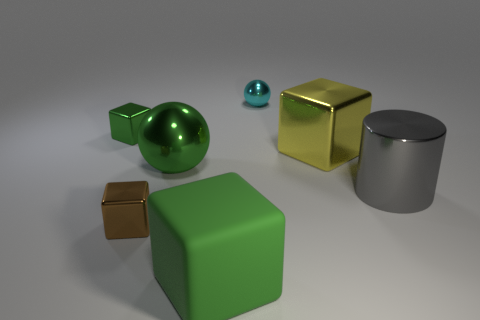There is a green block that is the same size as the green sphere; what material is it?
Provide a succinct answer. Rubber. What is the material of the big object that is the same color as the big sphere?
Your answer should be compact. Rubber. What color is the small sphere?
Offer a very short reply. Cyan. Does the tiny metallic thing that is in front of the metallic cylinder have the same shape as the gray metal thing?
Ensure brevity in your answer.  No. What number of things are big rubber things or cubes that are in front of the brown object?
Your response must be concise. 1. Is the big cube left of the cyan sphere made of the same material as the small green block?
Provide a short and direct response. No. Is there any other thing that has the same size as the green metallic sphere?
Your response must be concise. Yes. There is a small cube behind the small thing in front of the gray thing; what is its material?
Offer a very short reply. Metal. Are there more metal cubes that are behind the large matte object than brown metallic things to the left of the small green metallic cube?
Offer a terse response. Yes. What size is the yellow shiny block?
Give a very brief answer. Large. 